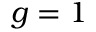<formula> <loc_0><loc_0><loc_500><loc_500>g = 1</formula> 